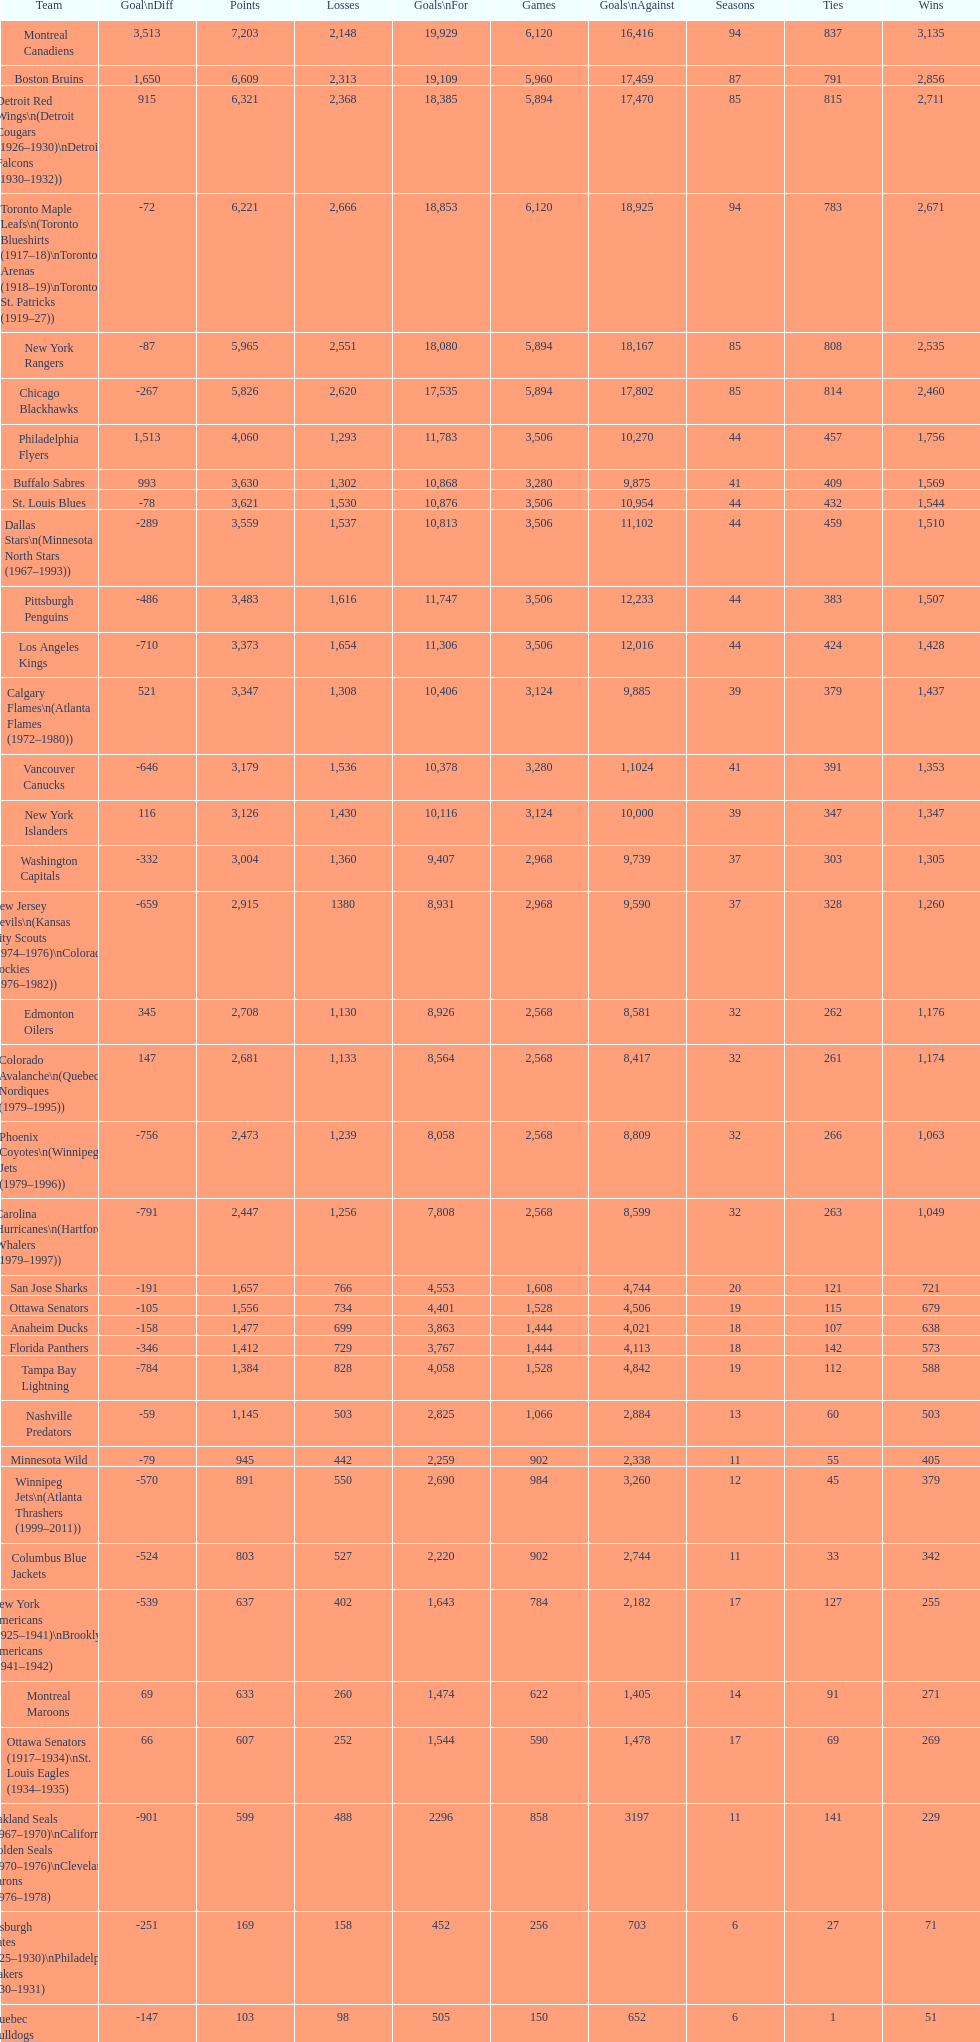Which team played the same amount of seasons as the canadiens? Toronto Maple Leafs. 